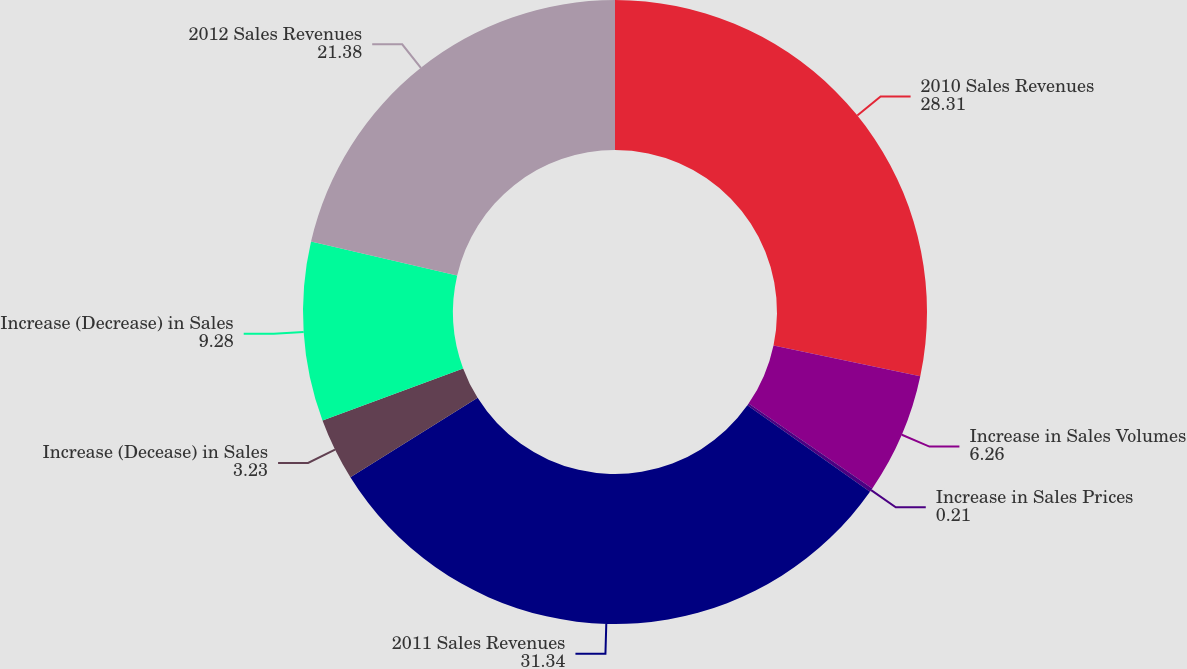Convert chart to OTSL. <chart><loc_0><loc_0><loc_500><loc_500><pie_chart><fcel>2010 Sales Revenues<fcel>Increase in Sales Volumes<fcel>Increase in Sales Prices<fcel>2011 Sales Revenues<fcel>Increase (Decease) in Sales<fcel>Increase (Decrease) in Sales<fcel>2012 Sales Revenues<nl><fcel>28.31%<fcel>6.26%<fcel>0.21%<fcel>31.34%<fcel>3.23%<fcel>9.28%<fcel>21.38%<nl></chart> 